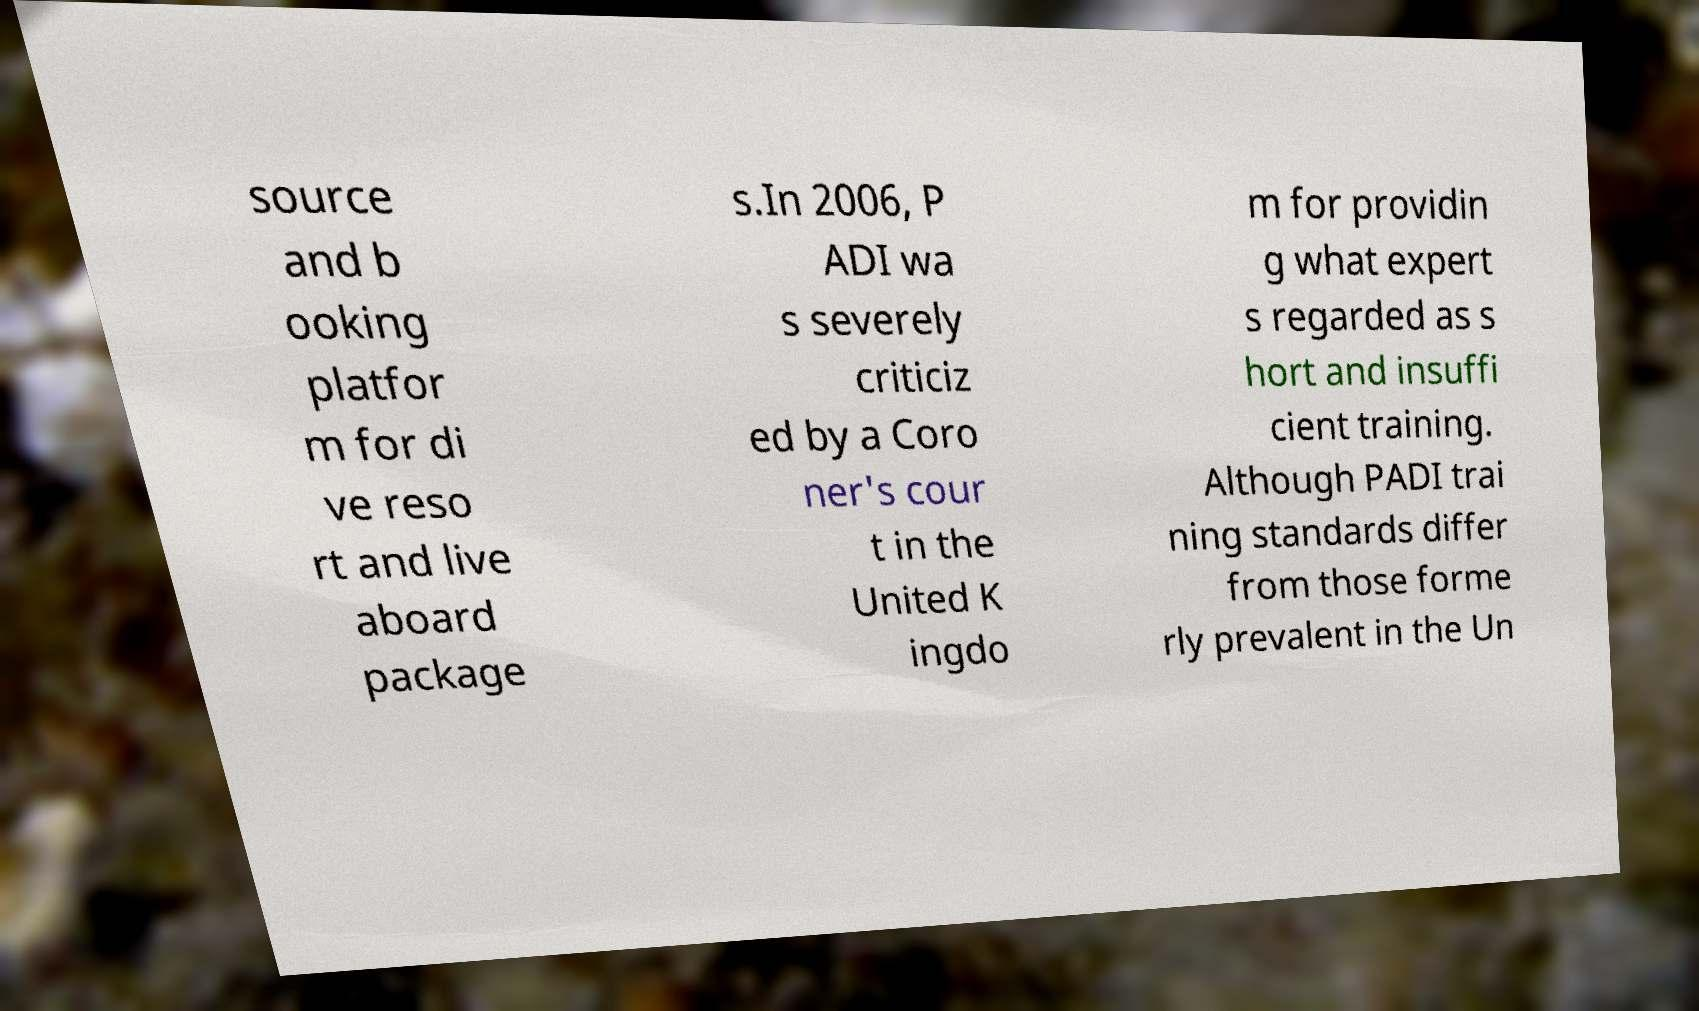Please read and relay the text visible in this image. What does it say? source and b ooking platfor m for di ve reso rt and live aboard package s.In 2006, P ADI wa s severely criticiz ed by a Coro ner's cour t in the United K ingdo m for providin g what expert s regarded as s hort and insuffi cient training. Although PADI trai ning standards differ from those forme rly prevalent in the Un 